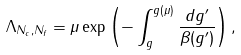Convert formula to latex. <formula><loc_0><loc_0><loc_500><loc_500>\Lambda _ { N _ { c } , N _ { f } } = \mu \exp \left ( - \int _ { g } ^ { g ( \mu ) } { \frac { d g ^ { \prime } } { \beta ( g ^ { \prime } ) } } \right ) ,</formula> 